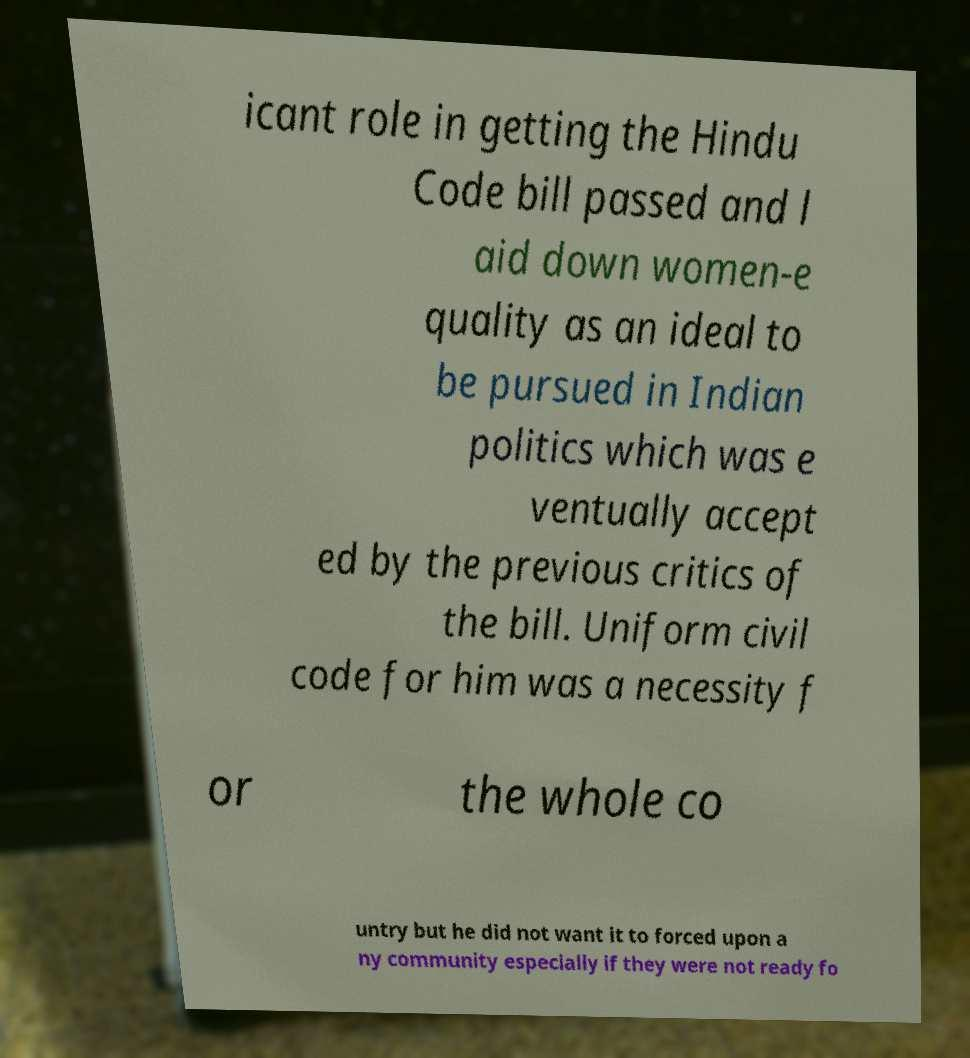For documentation purposes, I need the text within this image transcribed. Could you provide that? icant role in getting the Hindu Code bill passed and l aid down women-e quality as an ideal to be pursued in Indian politics which was e ventually accept ed by the previous critics of the bill. Uniform civil code for him was a necessity f or the whole co untry but he did not want it to forced upon a ny community especially if they were not ready fo 